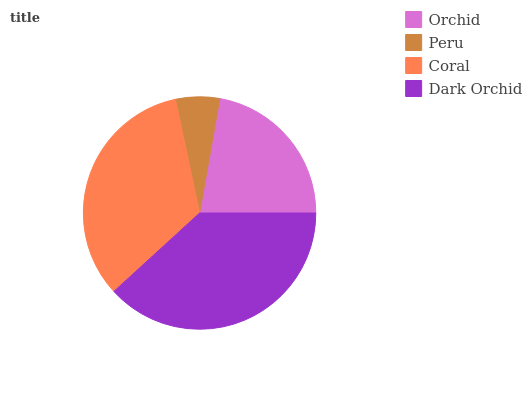Is Peru the minimum?
Answer yes or no. Yes. Is Dark Orchid the maximum?
Answer yes or no. Yes. Is Coral the minimum?
Answer yes or no. No. Is Coral the maximum?
Answer yes or no. No. Is Coral greater than Peru?
Answer yes or no. Yes. Is Peru less than Coral?
Answer yes or no. Yes. Is Peru greater than Coral?
Answer yes or no. No. Is Coral less than Peru?
Answer yes or no. No. Is Coral the high median?
Answer yes or no. Yes. Is Orchid the low median?
Answer yes or no. Yes. Is Peru the high median?
Answer yes or no. No. Is Peru the low median?
Answer yes or no. No. 